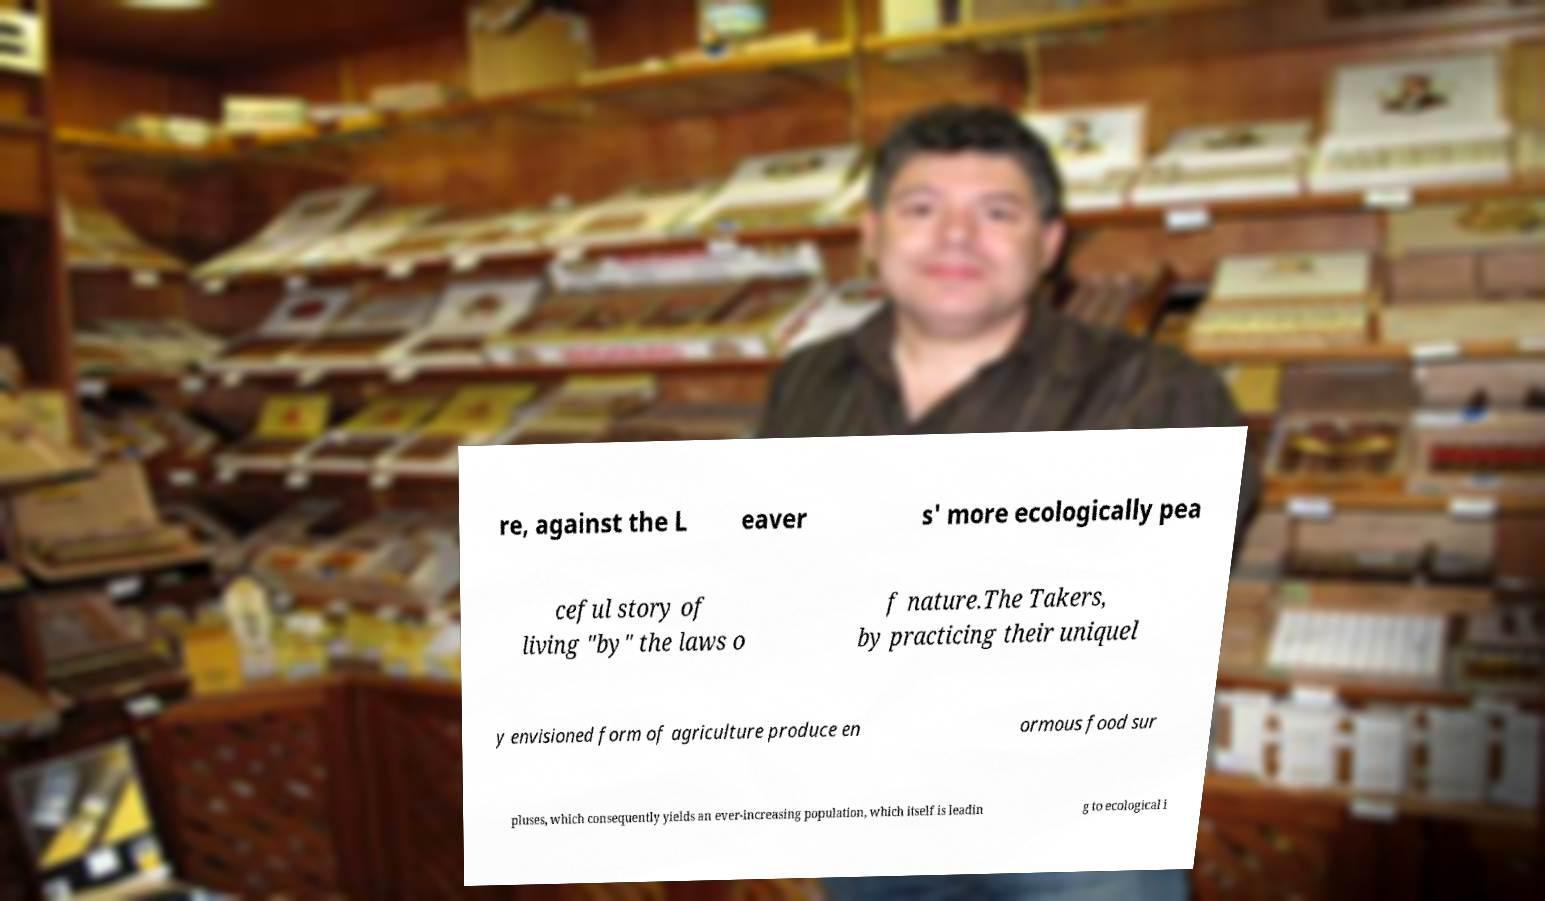For documentation purposes, I need the text within this image transcribed. Could you provide that? re, against the L eaver s' more ecologically pea ceful story of living "by" the laws o f nature.The Takers, by practicing their uniquel y envisioned form of agriculture produce en ormous food sur pluses, which consequently yields an ever-increasing population, which itself is leadin g to ecological i 